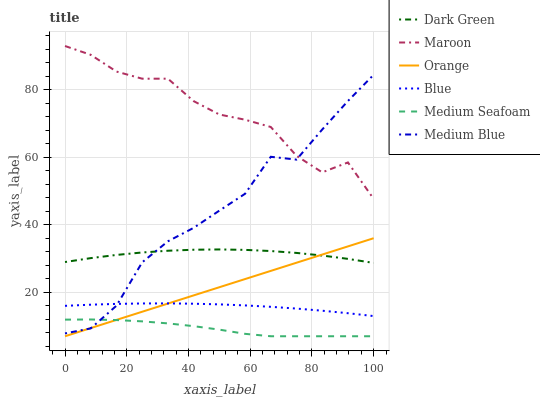Does Medium Seafoam have the minimum area under the curve?
Answer yes or no. Yes. Does Maroon have the maximum area under the curve?
Answer yes or no. Yes. Does Medium Blue have the minimum area under the curve?
Answer yes or no. No. Does Medium Blue have the maximum area under the curve?
Answer yes or no. No. Is Orange the smoothest?
Answer yes or no. Yes. Is Maroon the roughest?
Answer yes or no. Yes. Is Medium Blue the smoothest?
Answer yes or no. No. Is Medium Blue the roughest?
Answer yes or no. No. Does Orange have the lowest value?
Answer yes or no. Yes. Does Medium Blue have the lowest value?
Answer yes or no. No. Does Maroon have the highest value?
Answer yes or no. Yes. Does Medium Blue have the highest value?
Answer yes or no. No. Is Dark Green less than Maroon?
Answer yes or no. Yes. Is Maroon greater than Blue?
Answer yes or no. Yes. Does Blue intersect Orange?
Answer yes or no. Yes. Is Blue less than Orange?
Answer yes or no. No. Is Blue greater than Orange?
Answer yes or no. No. Does Dark Green intersect Maroon?
Answer yes or no. No. 